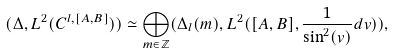Convert formula to latex. <formula><loc_0><loc_0><loc_500><loc_500>( \Delta , L ^ { 2 } ( C ^ { l , [ A , B ] } ) ) & \simeq \bigoplus _ { m \in \mathbb { Z } } ( \Delta _ { l } ( m ) , L ^ { 2 } ( [ A , B ] , \frac { 1 } { \sin ^ { 2 } ( v ) } d v ) ) ,</formula> 